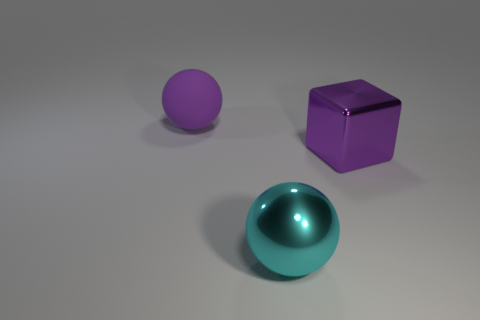There is a purple object right of the ball that is right of the purple sphere; what is it made of?
Make the answer very short. Metal. There is a large object that is in front of the big purple metal thing; is its color the same as the matte thing?
Ensure brevity in your answer.  No. Are there any other things that are the same material as the large purple sphere?
Your answer should be compact. No. What number of other big objects are the same shape as the large cyan object?
Offer a terse response. 1. What is the size of the purple block that is the same material as the cyan thing?
Your answer should be very brief. Large. Is there a large purple object that is behind the large purple thing to the right of the sphere that is right of the purple matte thing?
Your response must be concise. Yes. Does the thing that is right of the shiny ball have the same size as the cyan thing?
Make the answer very short. Yes. What number of purple rubber things are the same size as the rubber sphere?
Keep it short and to the point. 0. There is a thing that is the same color as the shiny block; what size is it?
Your answer should be compact. Large. Does the large cube have the same color as the big rubber object?
Provide a short and direct response. Yes. 